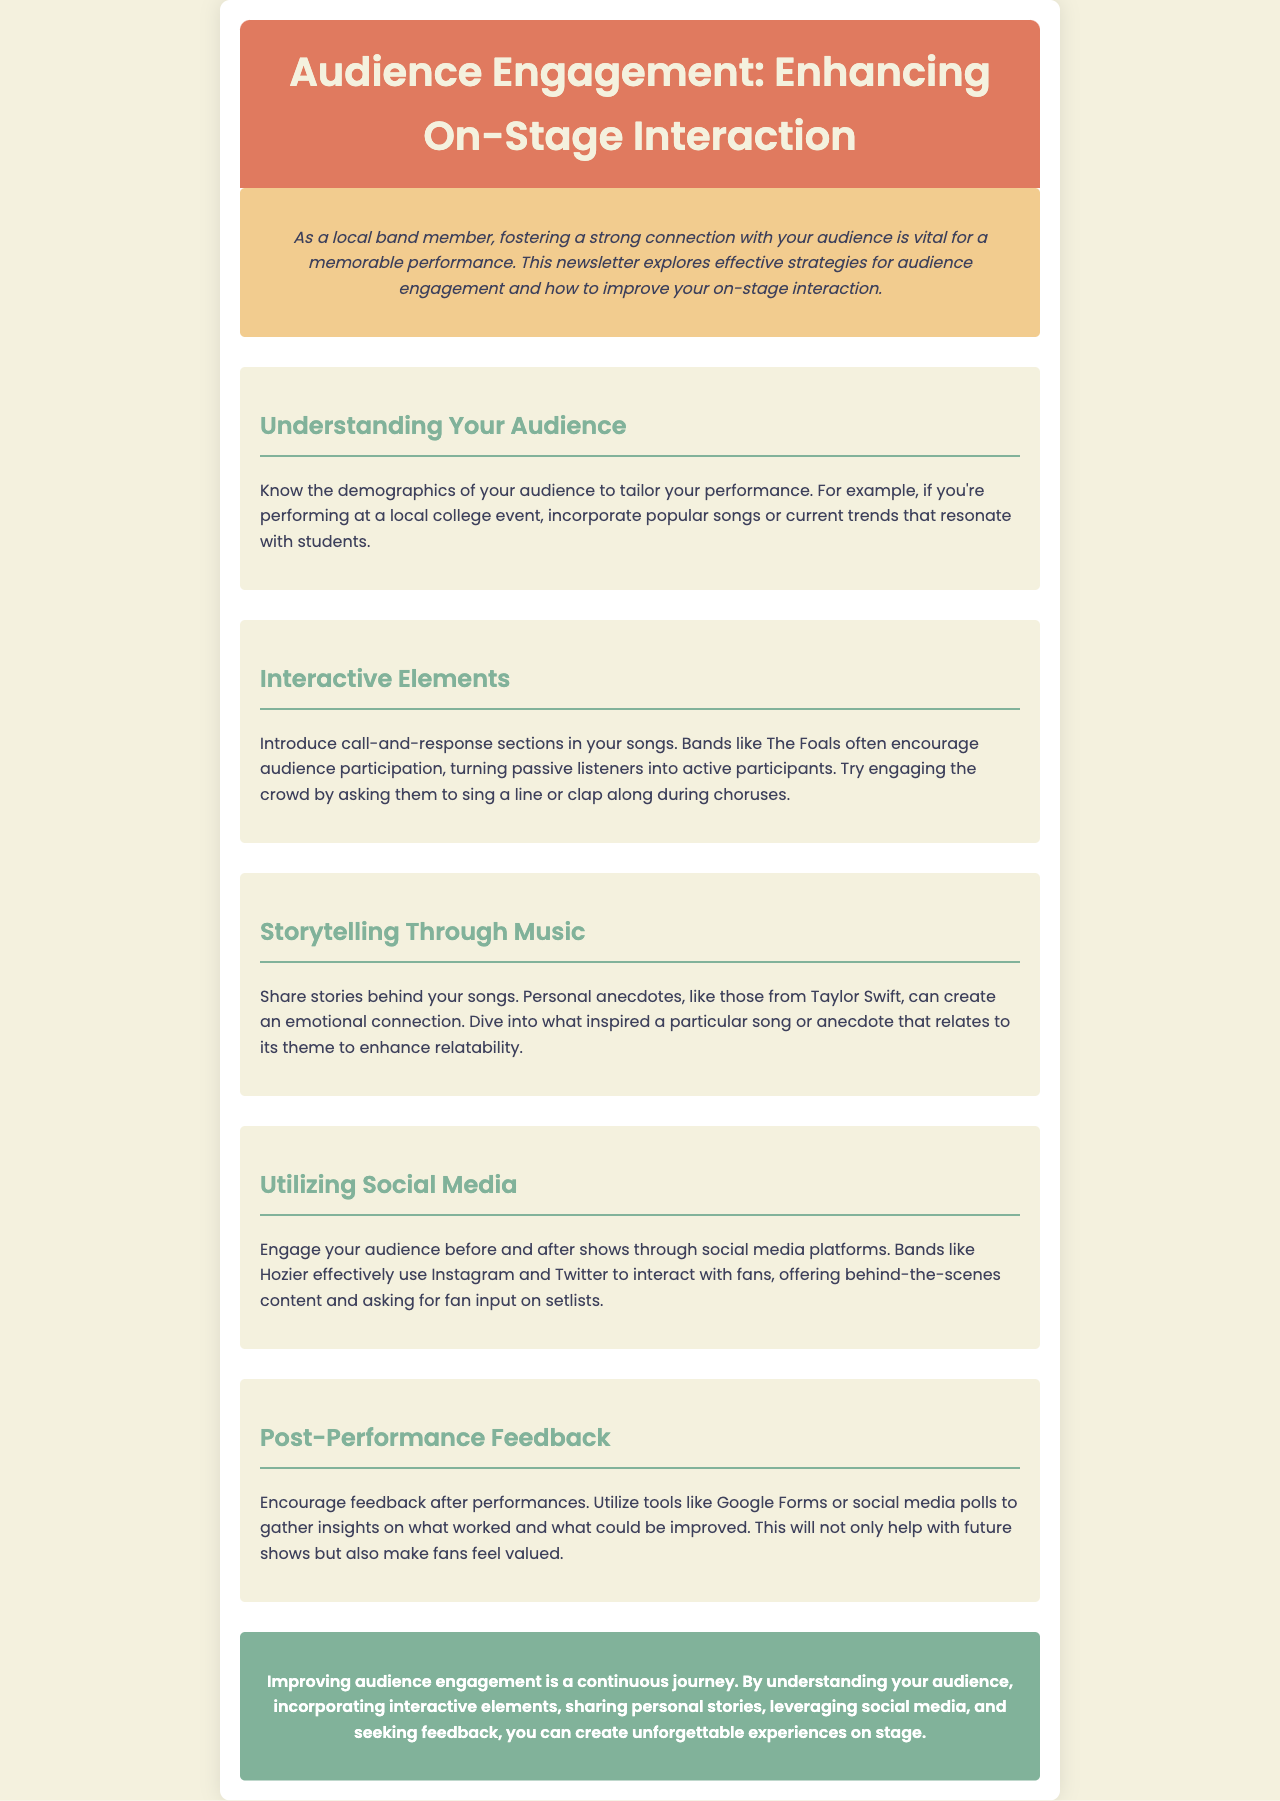what is the title of the newsletter? The title of the newsletter is indicated in the header section of the document.
Answer: Audience Engagement: Enhancing On-Stage Interaction what is one way to know your audience? The document suggests knowing the demographics of your audience to tailor your performance.
Answer: demographics which band is mentioned as an example for interactive elements? This band is referenced in the section that discusses how to involve the audience in performances.
Answer: The Foals what is a suggested tool for gathering post-performance feedback? The document lists effective methods for collecting audience feedback.
Answer: Google Forms what is the main benefit of sharing stories behind songs? The document states that sharing stories creates an emotional connection with the audience.
Answer: emotional connection how can social media be used to engage audiences? The document specifies that bands utilize social media to interact with fans before and after shows.
Answer: interact with fans what is the last section titled? The conclusion section wraps up the newsletter with key insights and takeaways.
Answer: Post-Performance Feedback what is the purpose of incorporating interactive elements? The newsletter highlights the importance of making the audience active participants in performances.
Answer: active participants 